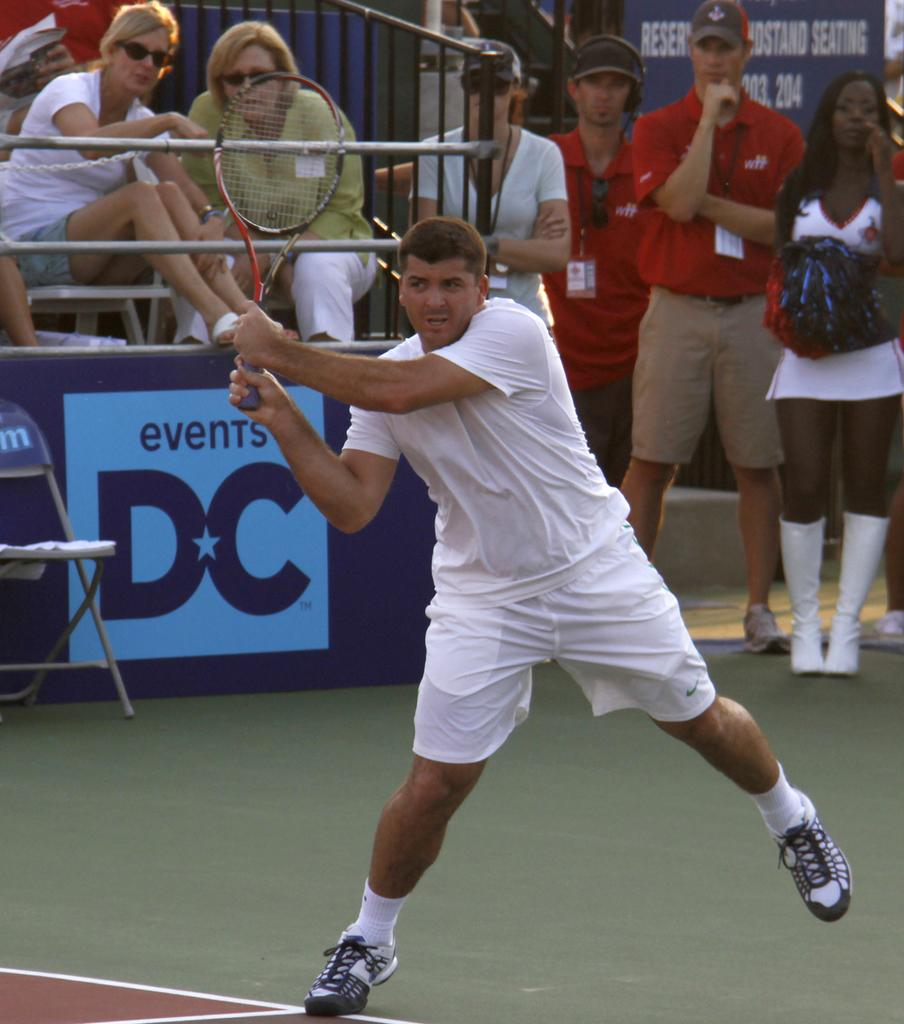What are the persons in the image doing? Some persons are sitting on chairs, while others are standing. Is there any specific object being held by one of the persons? Yes, one person is holding a bat. What type of furniture is present in the image? Chairs are present in the image. What type of sail can be seen in the image? There is no sail present in the image. How many beams are supporting the shelf in the image? There is no shelf or beam present in the image. 